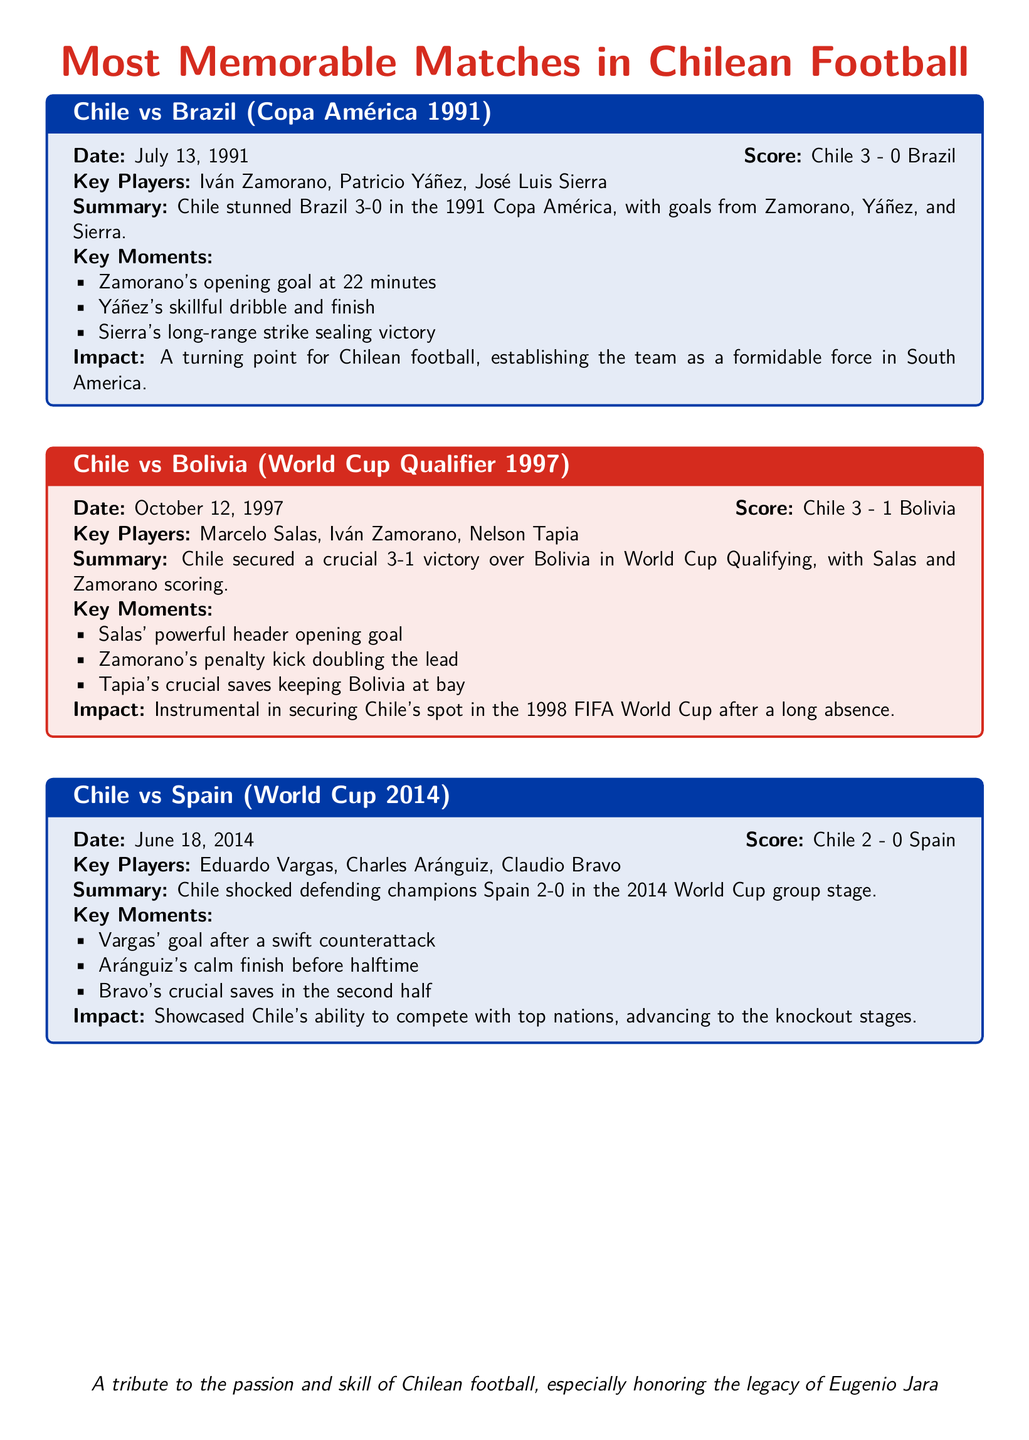What is the score of Chile vs Brazil in 1991? The score of the match is stated in the summary section of the document as Chile 3 - 0 Brazil.
Answer: Chile 3 - 0 Brazil Who scored the opening goal for Chile against Brazil? The opening goal for Chile was scored by Iván Zamorano, as mentioned in the key moments.
Answer: Iván Zamorano What year did Chile secure a victory over Bolivia in World Cup Qualifiers? The specific date of the match is provided in the document, which is October 12, 1997.
Answer: 1997 How many goals did Marcelo Salas score against Bolivia? The summary indicates that Salas was one of the players who scored, contributing to a total of three goals.
Answer: 1 Which player made crucial saves for Chile against Bolivia? The document specifies that Nelson Tapia made crucial saves, ensuring Bolivia couldn't score more.
Answer: Nelson Tapia How did Chile perform against Spain in the 2014 World Cup? The summary of the match clearly states that Chile won with a score of 2-0 against Spain.
Answer: Won 2-0 What key moment contributed to Chile's victory over Spain in 2014? The document highlights Vargas' goal after a swift counterattack as a key moment in the match.
Answer: Vargas' goal What was the overall impact of Chile's victory over Brazil in 1991? The impact is summarized as establishing Chile as a formidable force in South America.
Answer: Formidable force What color is the box for the match between Chile and Bolivia? The document describes the box for this match as being colored chilered!10.
Answer: chilered!10 